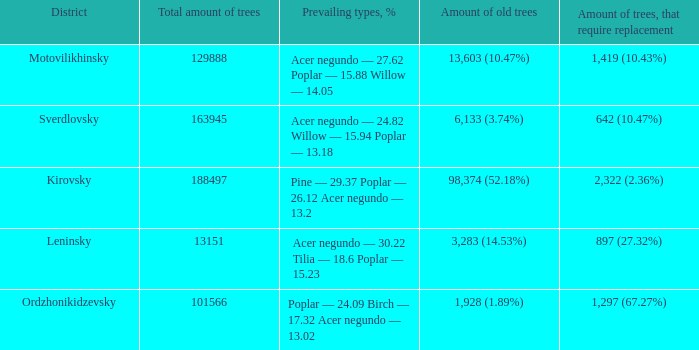What is the district when the total amount of trees is smaller than 150817.6878461314 and amount of old trees is 1,928 (1.89%)? Ordzhonikidzevsky. 